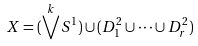<formula> <loc_0><loc_0><loc_500><loc_500>X = ( \bigvee ^ { k } S ^ { 1 } ) \cup ( D ^ { 2 } _ { 1 } \cup \cdots \cup D ^ { 2 } _ { r } )</formula> 